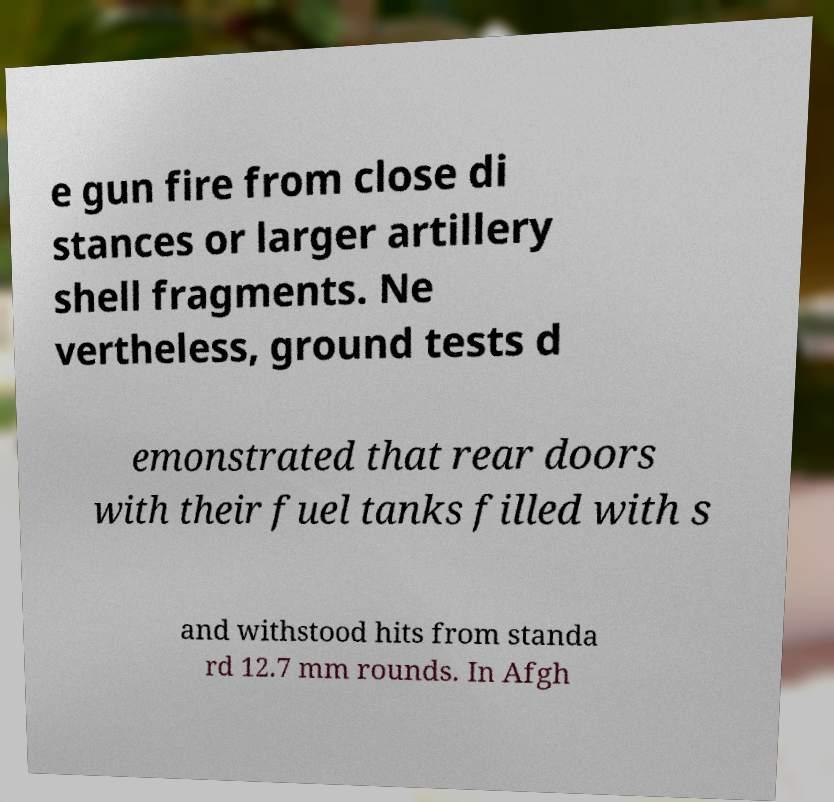I need the written content from this picture converted into text. Can you do that? e gun fire from close di stances or larger artillery shell fragments. Ne vertheless, ground tests d emonstrated that rear doors with their fuel tanks filled with s and withstood hits from standa rd 12.7 mm rounds. In Afgh 